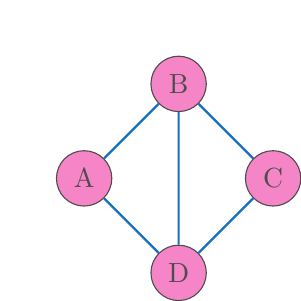Show me your answer to this math problem. To determine if the two game level structures are isomorphic, we need to check if there exists a bijective function between their vertex sets that preserves the adjacency relation. Let's approach this step-by-step:

1. Both graphs have 4 vertices, which is a necessary (but not sufficient) condition for isomorphism.

2. Both graphs have 5 edges, which is another necessary condition.

3. The degree sequence of both graphs is (3, 3, 3, 3), as each vertex in both graphs has 3 edges connected to it.

4. Now, let's try to find a bijective function that preserves adjacency:

   Let $f$ be a function from {A, B, C, D} to {1, 2, 3, 4}.

   We can start by mapping A to 1: $f(A) = 1$
   
   A is adjacent to B, C, and D. So 1 should be adjacent to 2, 3, and 4.
   This means B, C, and D must map to 2, 3, and 4 in some order.

   B is adjacent to D, so $f(B)$ must be adjacent to $f(D)$.
   The only way to satisfy this is: $f(B) = 2$ and $f(D) = 4$

   This leaves $f(C) = 3$

5. Let's verify this mapping:
   $f(A) = 1$, $f(B) = 2$, $f(C) = 3$, $f(D) = 4$

   - A is adjacent to B, C, D ⇔ 1 is adjacent to 2, 3, 4
   - B is adjacent to A, C, D ⇔ 2 is adjacent to 1, 3, 4
   - C is adjacent to A, B, D ⇔ 3 is adjacent to 1, 2, 4
   - D is adjacent to A, B, C ⇔ 4 is adjacent to 1, 2, 3

6. This mapping preserves all adjacencies, and it's bijective. Therefore, it's an isomorphism between the two graphs.

Thus, the two game level structures are isomorphic.
Answer: Yes, isomorphic. Isomorphism: $f(A) = 1$, $f(B) = 2$, $f(C) = 3$, $f(D) = 4$ 